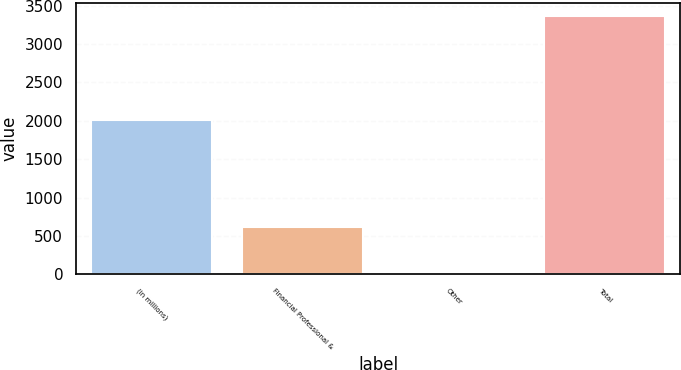Convert chart to OTSL. <chart><loc_0><loc_0><loc_500><loc_500><bar_chart><fcel>(in millions)<fcel>Financial Professional &<fcel>Other<fcel>Total<nl><fcel>2012<fcel>613<fcel>27<fcel>3365<nl></chart> 